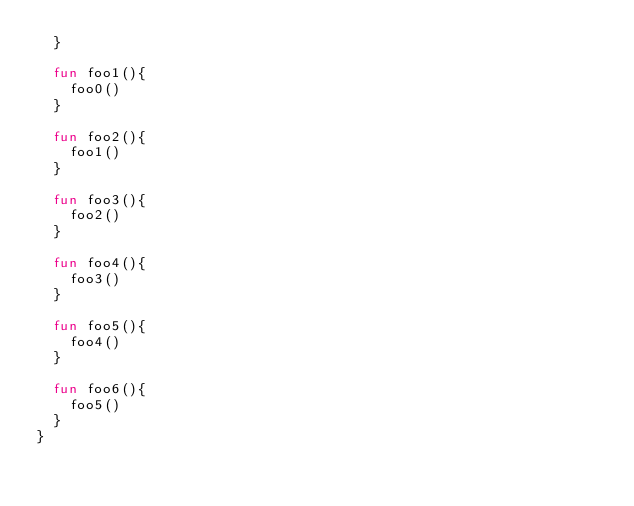<code> <loc_0><loc_0><loc_500><loc_500><_Kotlin_>  }

  fun foo1(){
    foo0()
  }

  fun foo2(){
    foo1()
  }

  fun foo3(){
    foo2()
  }

  fun foo4(){
    foo3()
  }

  fun foo5(){
    foo4()
  }

  fun foo6(){
    foo5()
  }
}</code> 